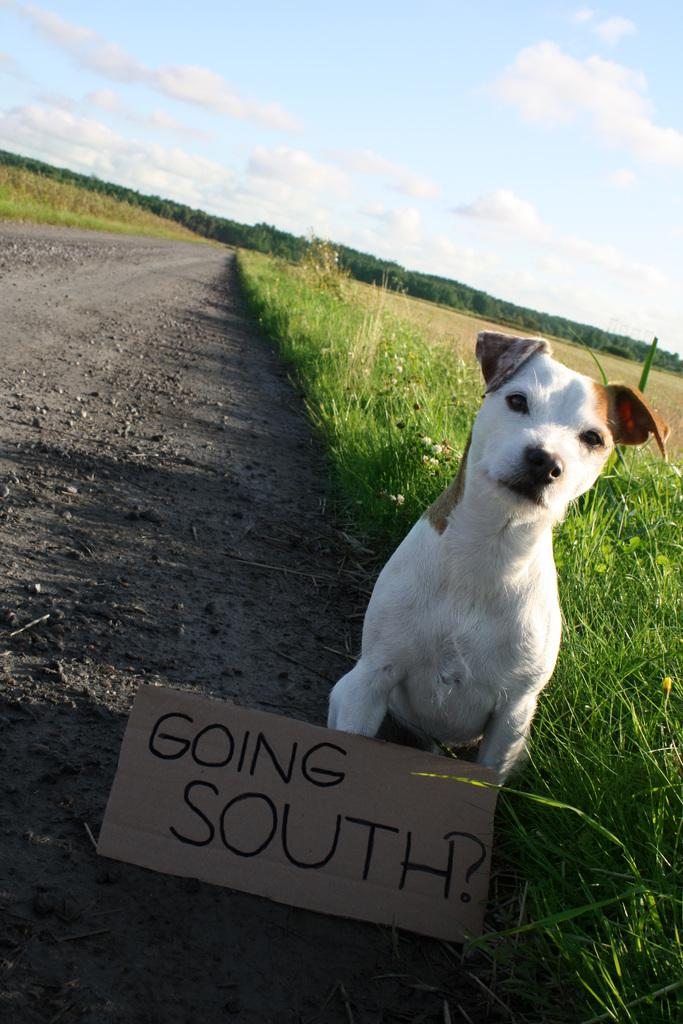What is located in the foreground of the image? There is a dog and text on cardboard in the foreground of the image. What type of vegetation can be seen in the background of the image? There are trees in the background of the image. What type of terrain is visible in the background of the image? There is grassland in the background of the image. What is visible in the sky in the background of the image? The sky is visible in the background of the image. What type of match is being played in the image? There is no match being played in the image; it features a dog and text on cardboard in the foreground, with trees, grassland, and the sky visible in the background. 